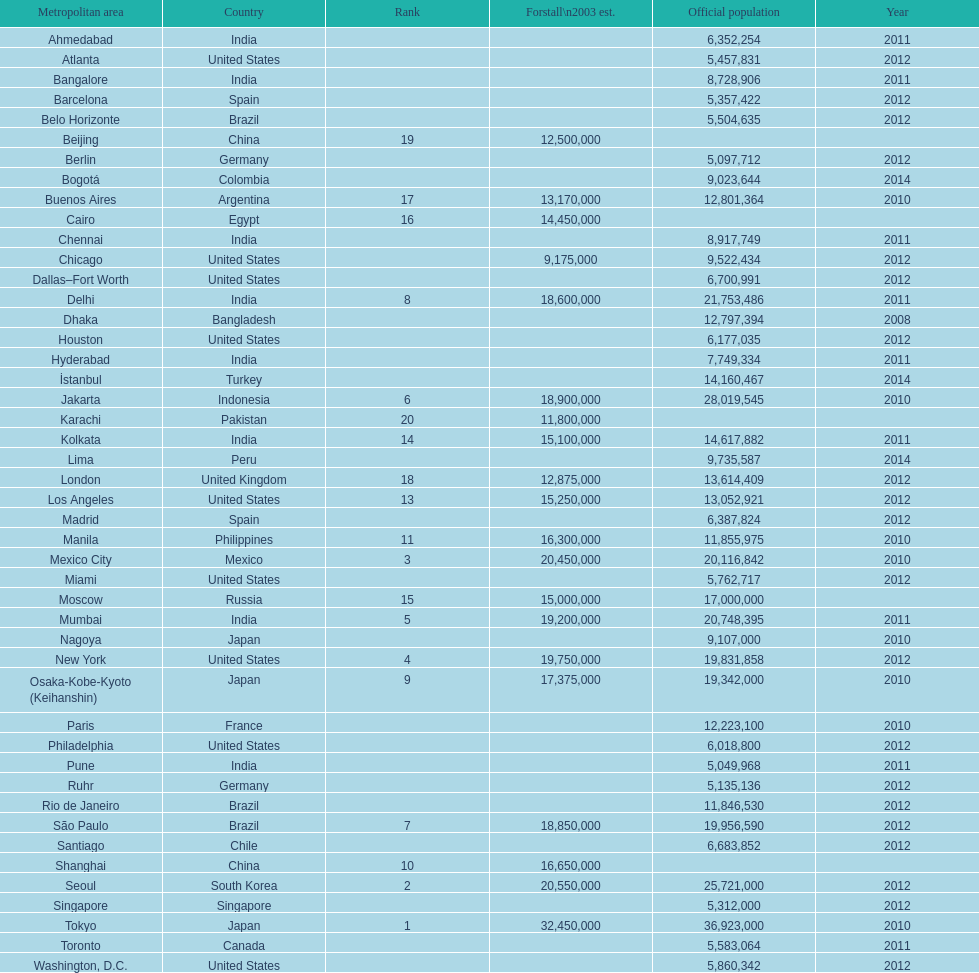Which region is mentioned above chicago? Chennai. Can you give me this table as a dict? {'header': ['Metropolitan area', 'Country', 'Rank', 'Forstall\\n2003 est.', 'Official population', 'Year'], 'rows': [['Ahmedabad', 'India', '', '', '6,352,254', '2011'], ['Atlanta', 'United States', '', '', '5,457,831', '2012'], ['Bangalore', 'India', '', '', '8,728,906', '2011'], ['Barcelona', 'Spain', '', '', '5,357,422', '2012'], ['Belo Horizonte', 'Brazil', '', '', '5,504,635', '2012'], ['Beijing', 'China', '19', '12,500,000', '', ''], ['Berlin', 'Germany', '', '', '5,097,712', '2012'], ['Bogotá', 'Colombia', '', '', '9,023,644', '2014'], ['Buenos Aires', 'Argentina', '17', '13,170,000', '12,801,364', '2010'], ['Cairo', 'Egypt', '16', '14,450,000', '', ''], ['Chennai', 'India', '', '', '8,917,749', '2011'], ['Chicago', 'United States', '', '9,175,000', '9,522,434', '2012'], ['Dallas–Fort Worth', 'United States', '', '', '6,700,991', '2012'], ['Delhi', 'India', '8', '18,600,000', '21,753,486', '2011'], ['Dhaka', 'Bangladesh', '', '', '12,797,394', '2008'], ['Houston', 'United States', '', '', '6,177,035', '2012'], ['Hyderabad', 'India', '', '', '7,749,334', '2011'], ['İstanbul', 'Turkey', '', '', '14,160,467', '2014'], ['Jakarta', 'Indonesia', '6', '18,900,000', '28,019,545', '2010'], ['Karachi', 'Pakistan', '20', '11,800,000', '', ''], ['Kolkata', 'India', '14', '15,100,000', '14,617,882', '2011'], ['Lima', 'Peru', '', '', '9,735,587', '2014'], ['London', 'United Kingdom', '18', '12,875,000', '13,614,409', '2012'], ['Los Angeles', 'United States', '13', '15,250,000', '13,052,921', '2012'], ['Madrid', 'Spain', '', '', '6,387,824', '2012'], ['Manila', 'Philippines', '11', '16,300,000', '11,855,975', '2010'], ['Mexico City', 'Mexico', '3', '20,450,000', '20,116,842', '2010'], ['Miami', 'United States', '', '', '5,762,717', '2012'], ['Moscow', 'Russia', '15', '15,000,000', '17,000,000', ''], ['Mumbai', 'India', '5', '19,200,000', '20,748,395', '2011'], ['Nagoya', 'Japan', '', '', '9,107,000', '2010'], ['New York', 'United States', '4', '19,750,000', '19,831,858', '2012'], ['Osaka-Kobe-Kyoto (Keihanshin)', 'Japan', '9', '17,375,000', '19,342,000', '2010'], ['Paris', 'France', '', '', '12,223,100', '2010'], ['Philadelphia', 'United States', '', '', '6,018,800', '2012'], ['Pune', 'India', '', '', '5,049,968', '2011'], ['Ruhr', 'Germany', '', '', '5,135,136', '2012'], ['Rio de Janeiro', 'Brazil', '', '', '11,846,530', '2012'], ['São Paulo', 'Brazil', '7', '18,850,000', '19,956,590', '2012'], ['Santiago', 'Chile', '', '', '6,683,852', '2012'], ['Shanghai', 'China', '10', '16,650,000', '', ''], ['Seoul', 'South Korea', '2', '20,550,000', '25,721,000', '2012'], ['Singapore', 'Singapore', '', '', '5,312,000', '2012'], ['Tokyo', 'Japan', '1', '32,450,000', '36,923,000', '2010'], ['Toronto', 'Canada', '', '', '5,583,064', '2011'], ['Washington, D.C.', 'United States', '', '', '5,860,342', '2012']]} 